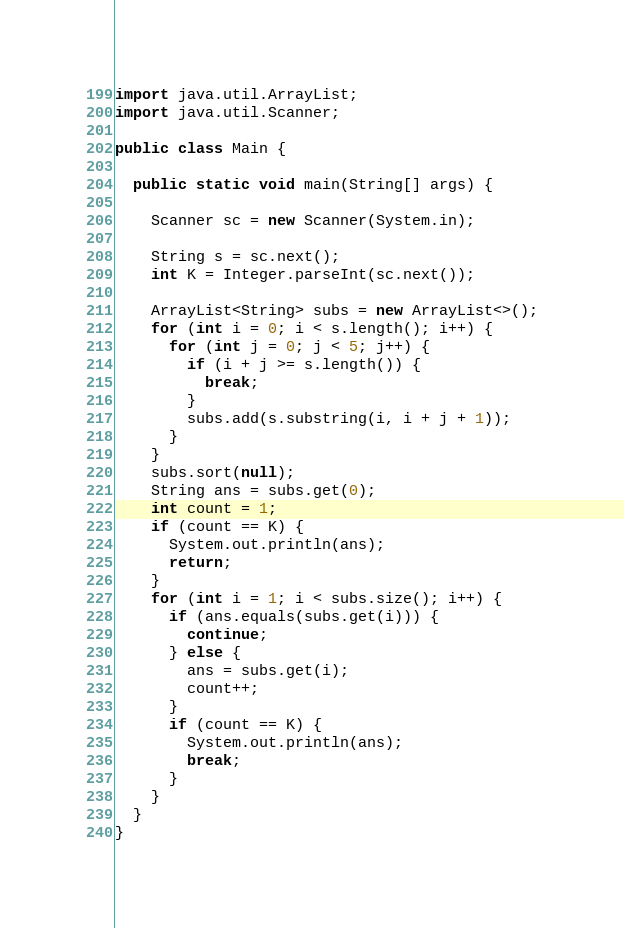Convert code to text. <code><loc_0><loc_0><loc_500><loc_500><_Java_>import java.util.ArrayList;
import java.util.Scanner;

public class Main {

  public static void main(String[] args) {

    Scanner sc = new Scanner(System.in);

    String s = sc.next();
    int K = Integer.parseInt(sc.next());

    ArrayList<String> subs = new ArrayList<>();
    for (int i = 0; i < s.length(); i++) {
      for (int j = 0; j < 5; j++) {
        if (i + j >= s.length()) {
          break;
        }
        subs.add(s.substring(i, i + j + 1));
      }
    }
    subs.sort(null);
    String ans = subs.get(0);
    int count = 1;
    if (count == K) {
      System.out.println(ans);
      return;
    }
    for (int i = 1; i < subs.size(); i++) {
      if (ans.equals(subs.get(i))) {
        continue;
      } else {
        ans = subs.get(i);
        count++;
      }
      if (count == K) {
        System.out.println(ans);
        break;
      }
    }
  }
}</code> 